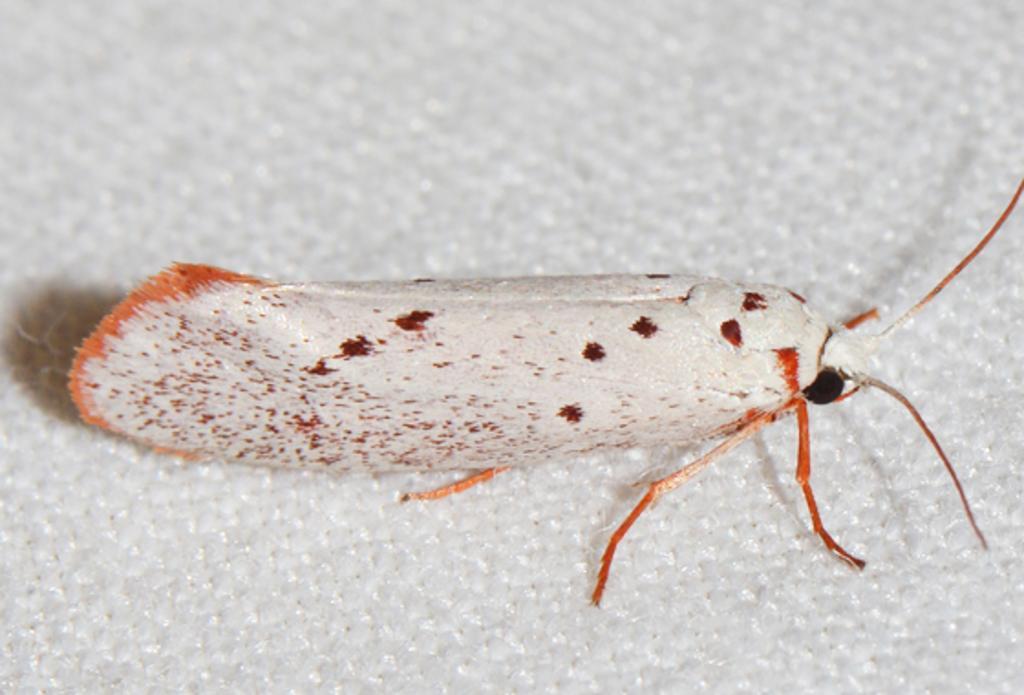In one or two sentences, can you explain what this image depicts? In this image we can see an insect on the white color surface. 